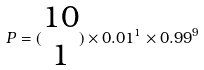<formula> <loc_0><loc_0><loc_500><loc_500>P = ( \begin{matrix} 1 0 \\ 1 \end{matrix} ) \times 0 . 0 1 ^ { 1 } \times 0 . 9 9 ^ { 9 }</formula> 